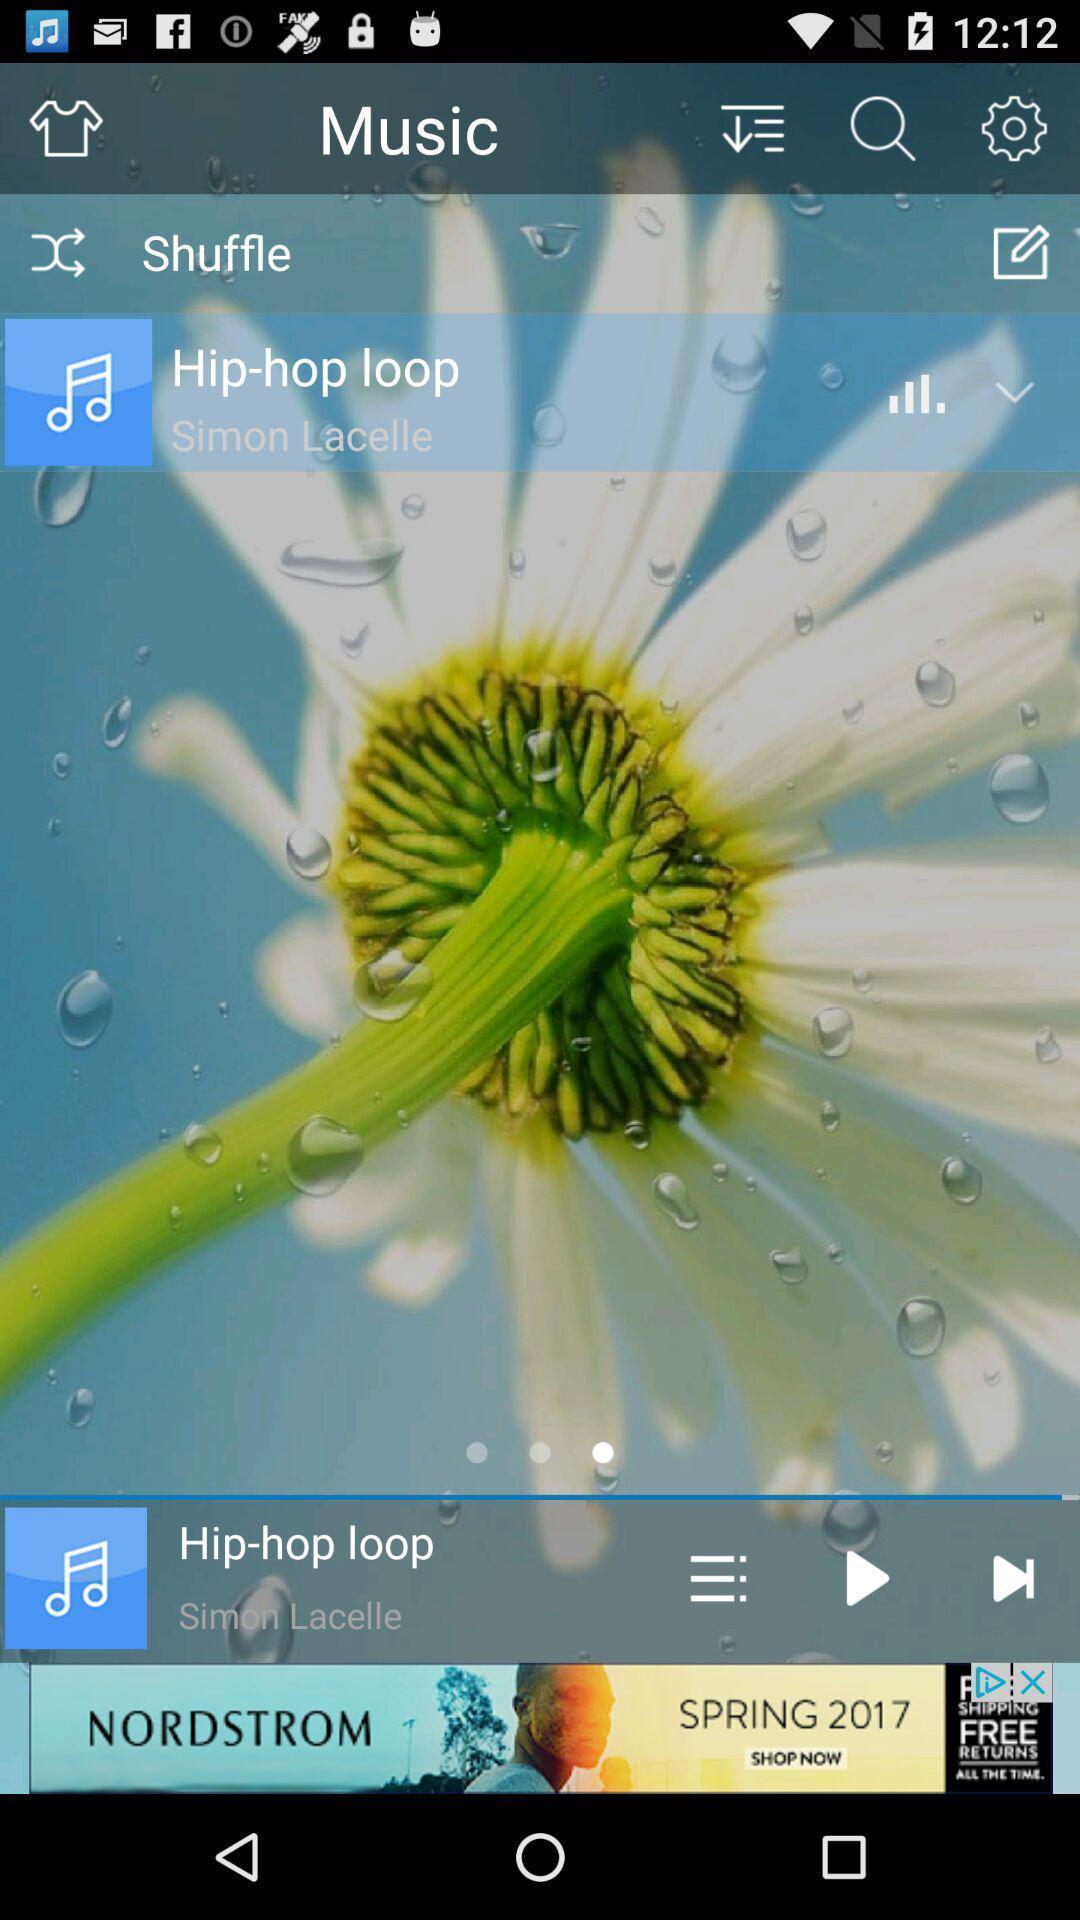Provide a detailed account of this screenshot. Screen displaying page of an music application. 